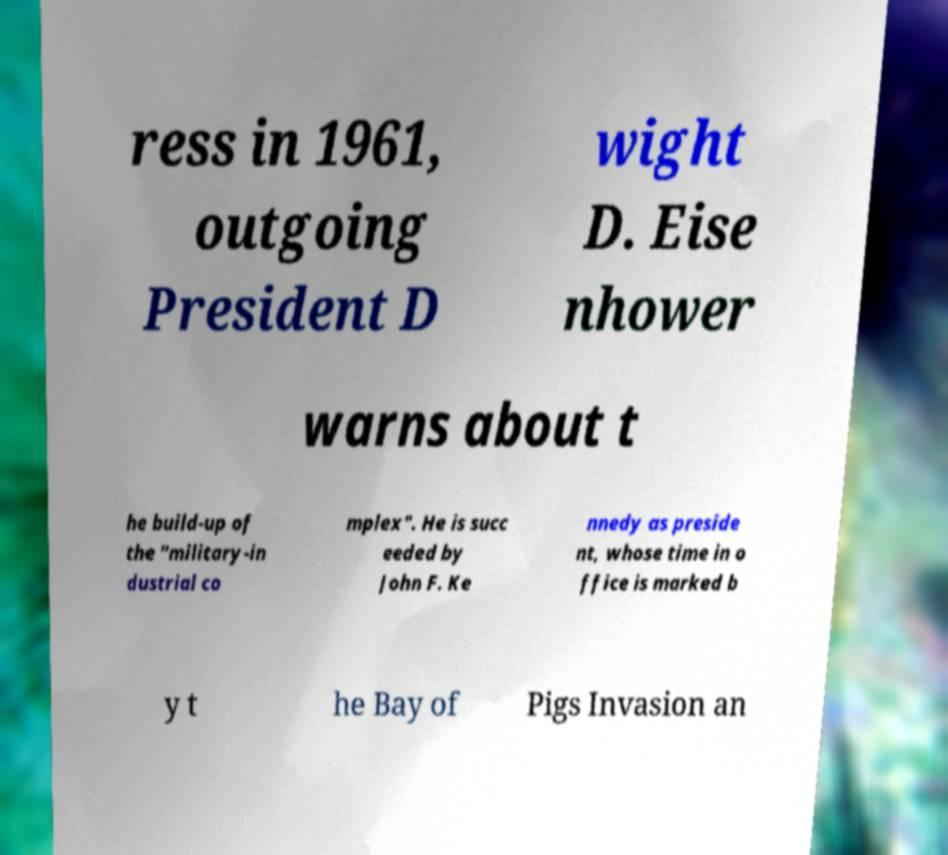Can you read and provide the text displayed in the image?This photo seems to have some interesting text. Can you extract and type it out for me? ress in 1961, outgoing President D wight D. Eise nhower warns about t he build-up of the "military-in dustrial co mplex". He is succ eeded by John F. Ke nnedy as preside nt, whose time in o ffice is marked b y t he Bay of Pigs Invasion an 